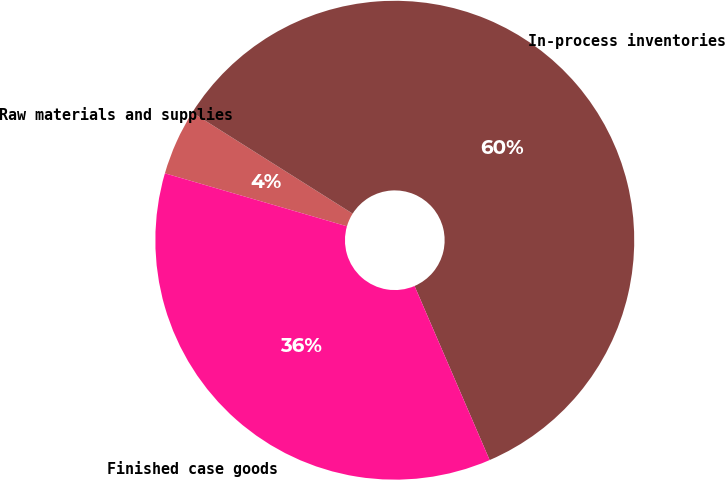Convert chart. <chart><loc_0><loc_0><loc_500><loc_500><pie_chart><fcel>Raw materials and supplies<fcel>In-process inventories<fcel>Finished case goods<nl><fcel>4.45%<fcel>59.56%<fcel>35.99%<nl></chart> 